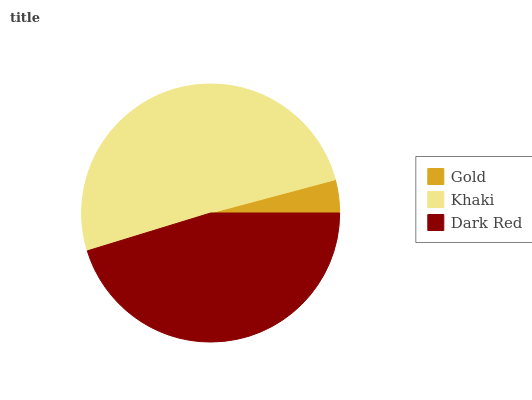Is Gold the minimum?
Answer yes or no. Yes. Is Khaki the maximum?
Answer yes or no. Yes. Is Dark Red the minimum?
Answer yes or no. No. Is Dark Red the maximum?
Answer yes or no. No. Is Khaki greater than Dark Red?
Answer yes or no. Yes. Is Dark Red less than Khaki?
Answer yes or no. Yes. Is Dark Red greater than Khaki?
Answer yes or no. No. Is Khaki less than Dark Red?
Answer yes or no. No. Is Dark Red the high median?
Answer yes or no. Yes. Is Dark Red the low median?
Answer yes or no. Yes. Is Khaki the high median?
Answer yes or no. No. Is Gold the low median?
Answer yes or no. No. 